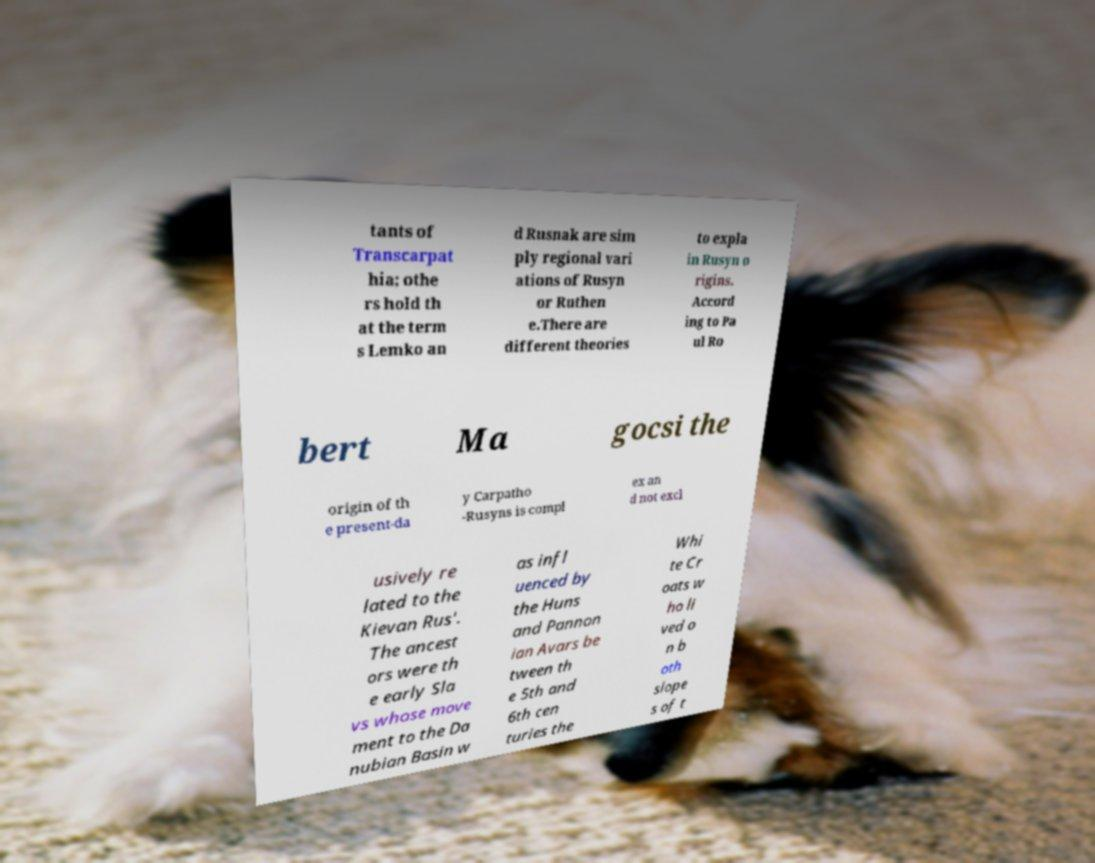Can you read and provide the text displayed in the image?This photo seems to have some interesting text. Can you extract and type it out for me? tants of Transcarpat hia; othe rs hold th at the term s Lemko an d Rusnak are sim ply regional vari ations of Rusyn or Ruthen e.There are different theories to expla in Rusyn o rigins. Accord ing to Pa ul Ro bert Ma gocsi the origin of th e present-da y Carpatho -Rusyns is compl ex an d not excl usively re lated to the Kievan Rus'. The ancest ors were th e early Sla vs whose move ment to the Da nubian Basin w as infl uenced by the Huns and Pannon ian Avars be tween th e 5th and 6th cen turies the Whi te Cr oats w ho li ved o n b oth slope s of t 